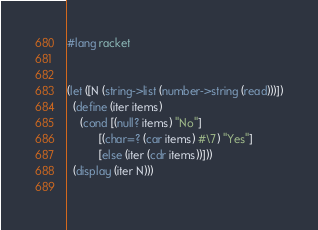Convert code to text. <code><loc_0><loc_0><loc_500><loc_500><_Racket_>#lang racket


(let ([N (string->list (number->string (read)))])
  (define (iter items)
    (cond [(null? items) "No"]
          [(char=? (car items) #\7) "Yes"]
          [else (iter (cdr items))]))
  (display (iter N)))
  
</code> 